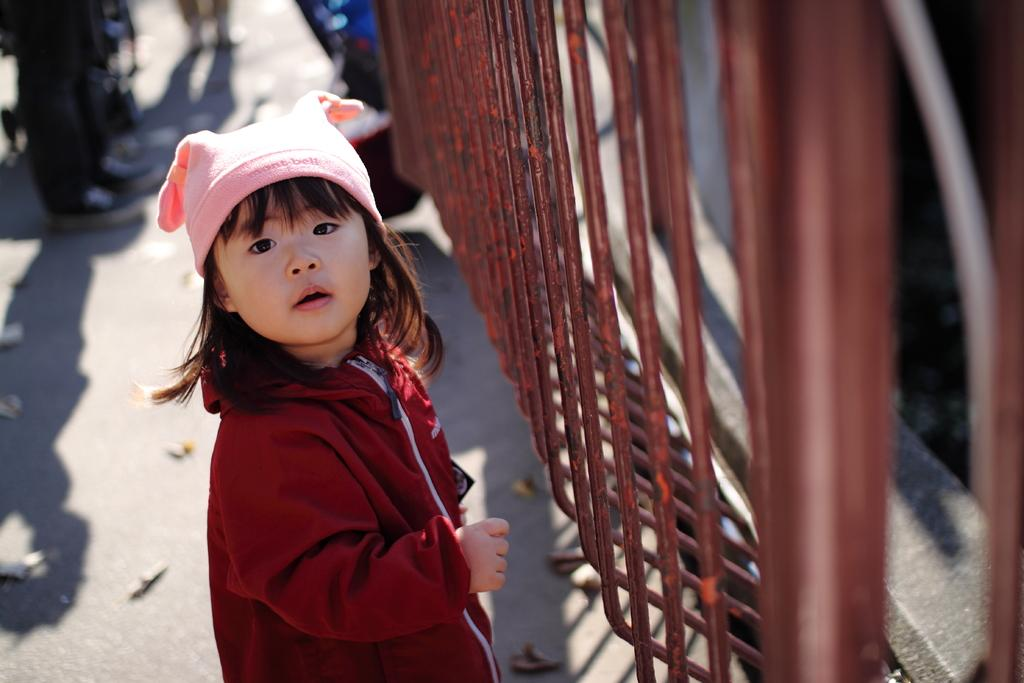Who is the main subject in the image? There is a girl standing in the center of the image. What is the girl wearing on her head? The girl is wearing a cap. What is in front of the girl in the image? There is a fence before the girl. What can be seen in the distance behind the girl? There are people visible in the background of the image. What type of leaf is being used as a screw in the image? There is no leaf or screw present in the image. How does the trail lead to the girl in the image? There is no trail visible in the image; it only features the girl, a fence, and people in the background. 